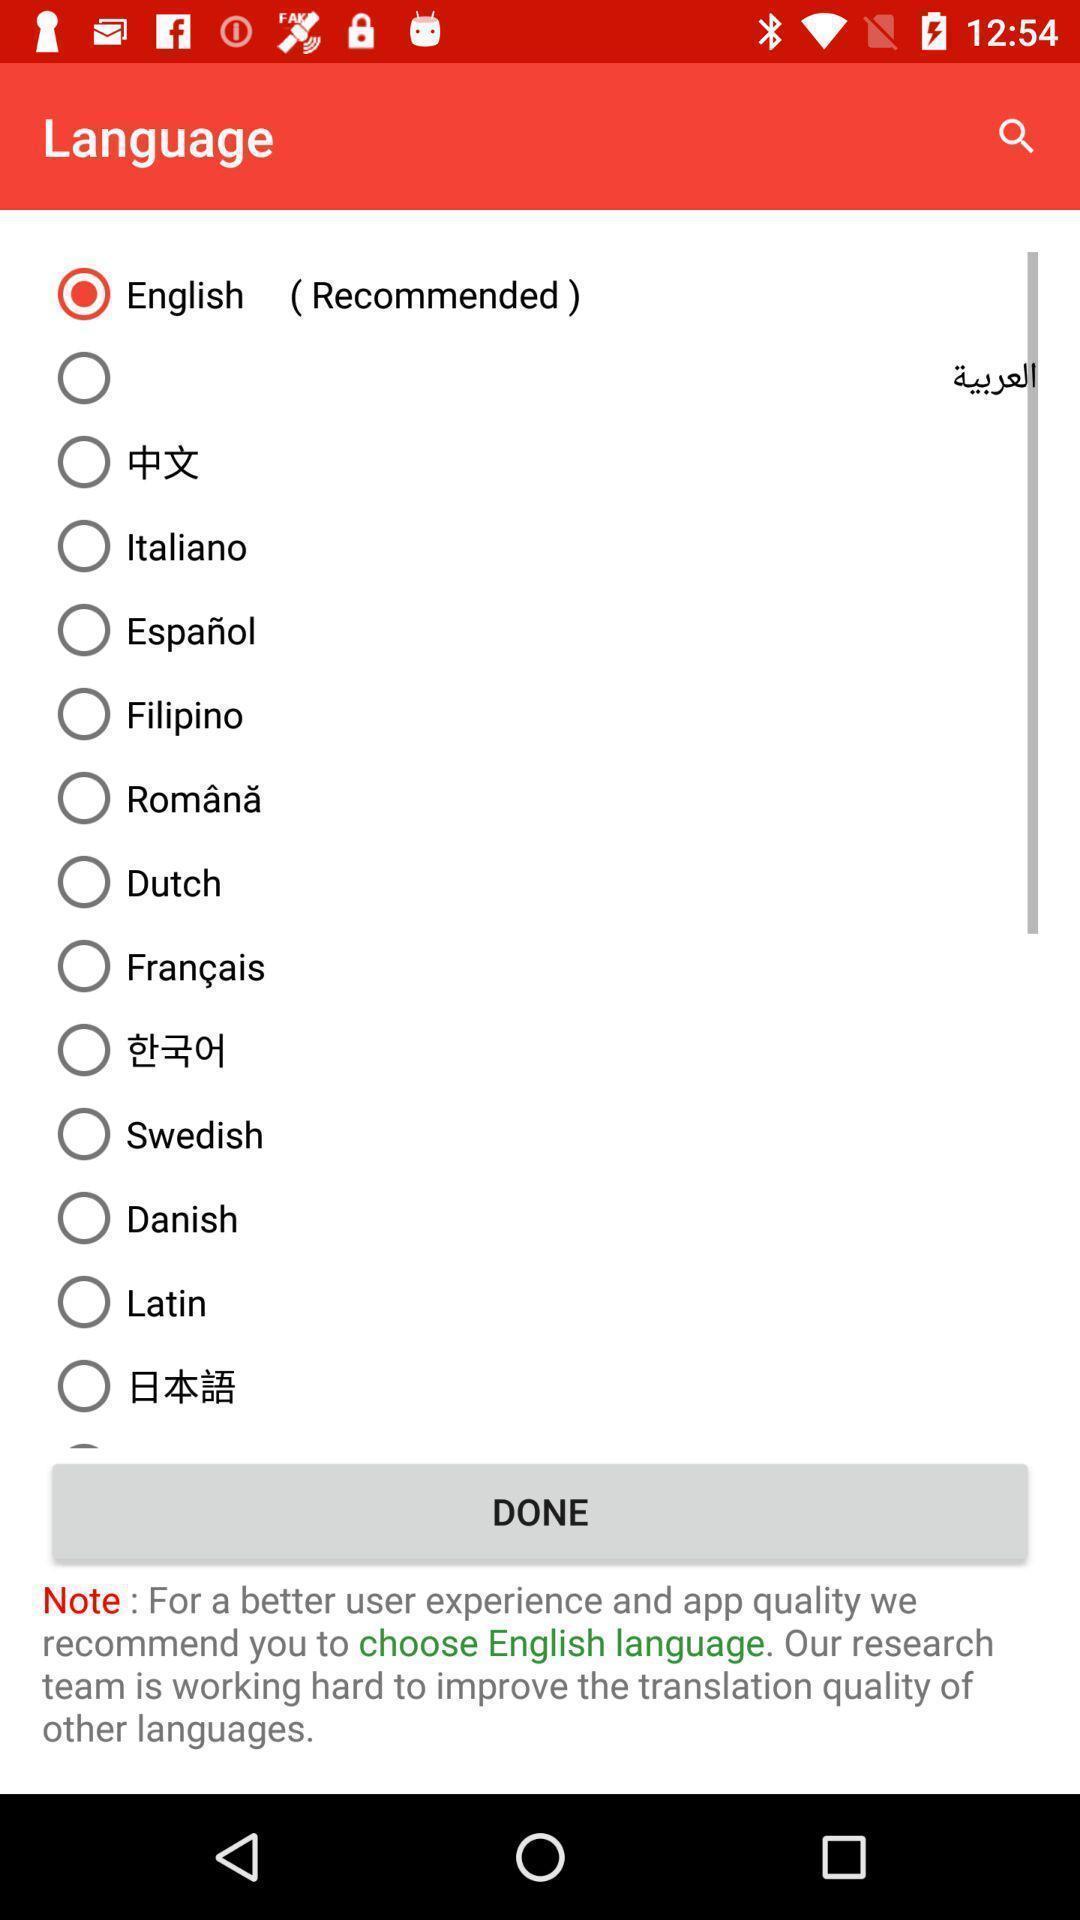Provide a description of this screenshot. Screen showing list of languages to select. 